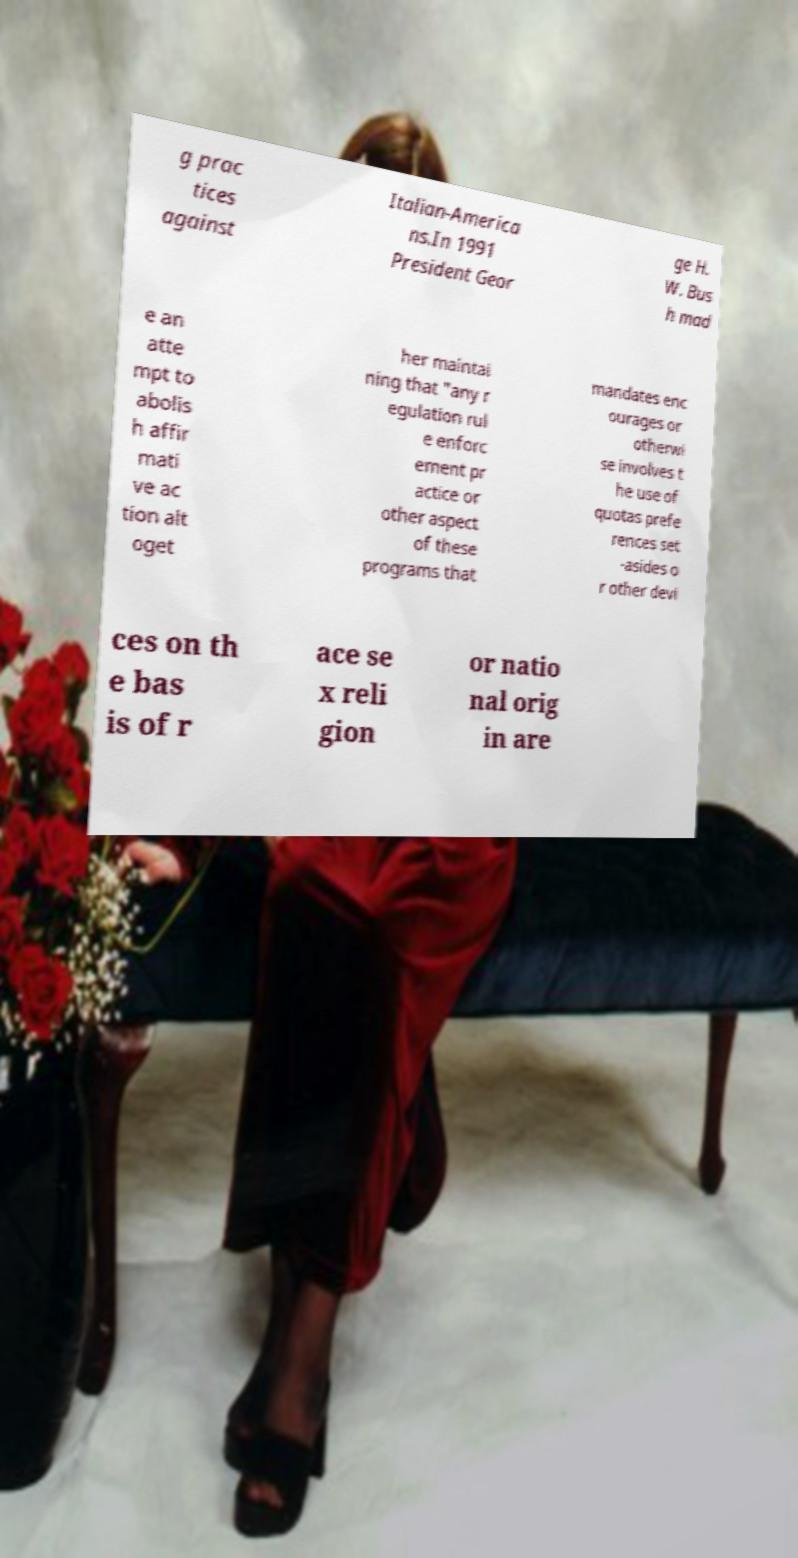There's text embedded in this image that I need extracted. Can you transcribe it verbatim? g prac tices against Italian-America ns.In 1991 President Geor ge H. W. Bus h mad e an atte mpt to abolis h affir mati ve ac tion alt oget her maintai ning that "any r egulation rul e enforc ement pr actice or other aspect of these programs that mandates enc ourages or otherwi se involves t he use of quotas prefe rences set -asides o r other devi ces on th e bas is of r ace se x reli gion or natio nal orig in are 